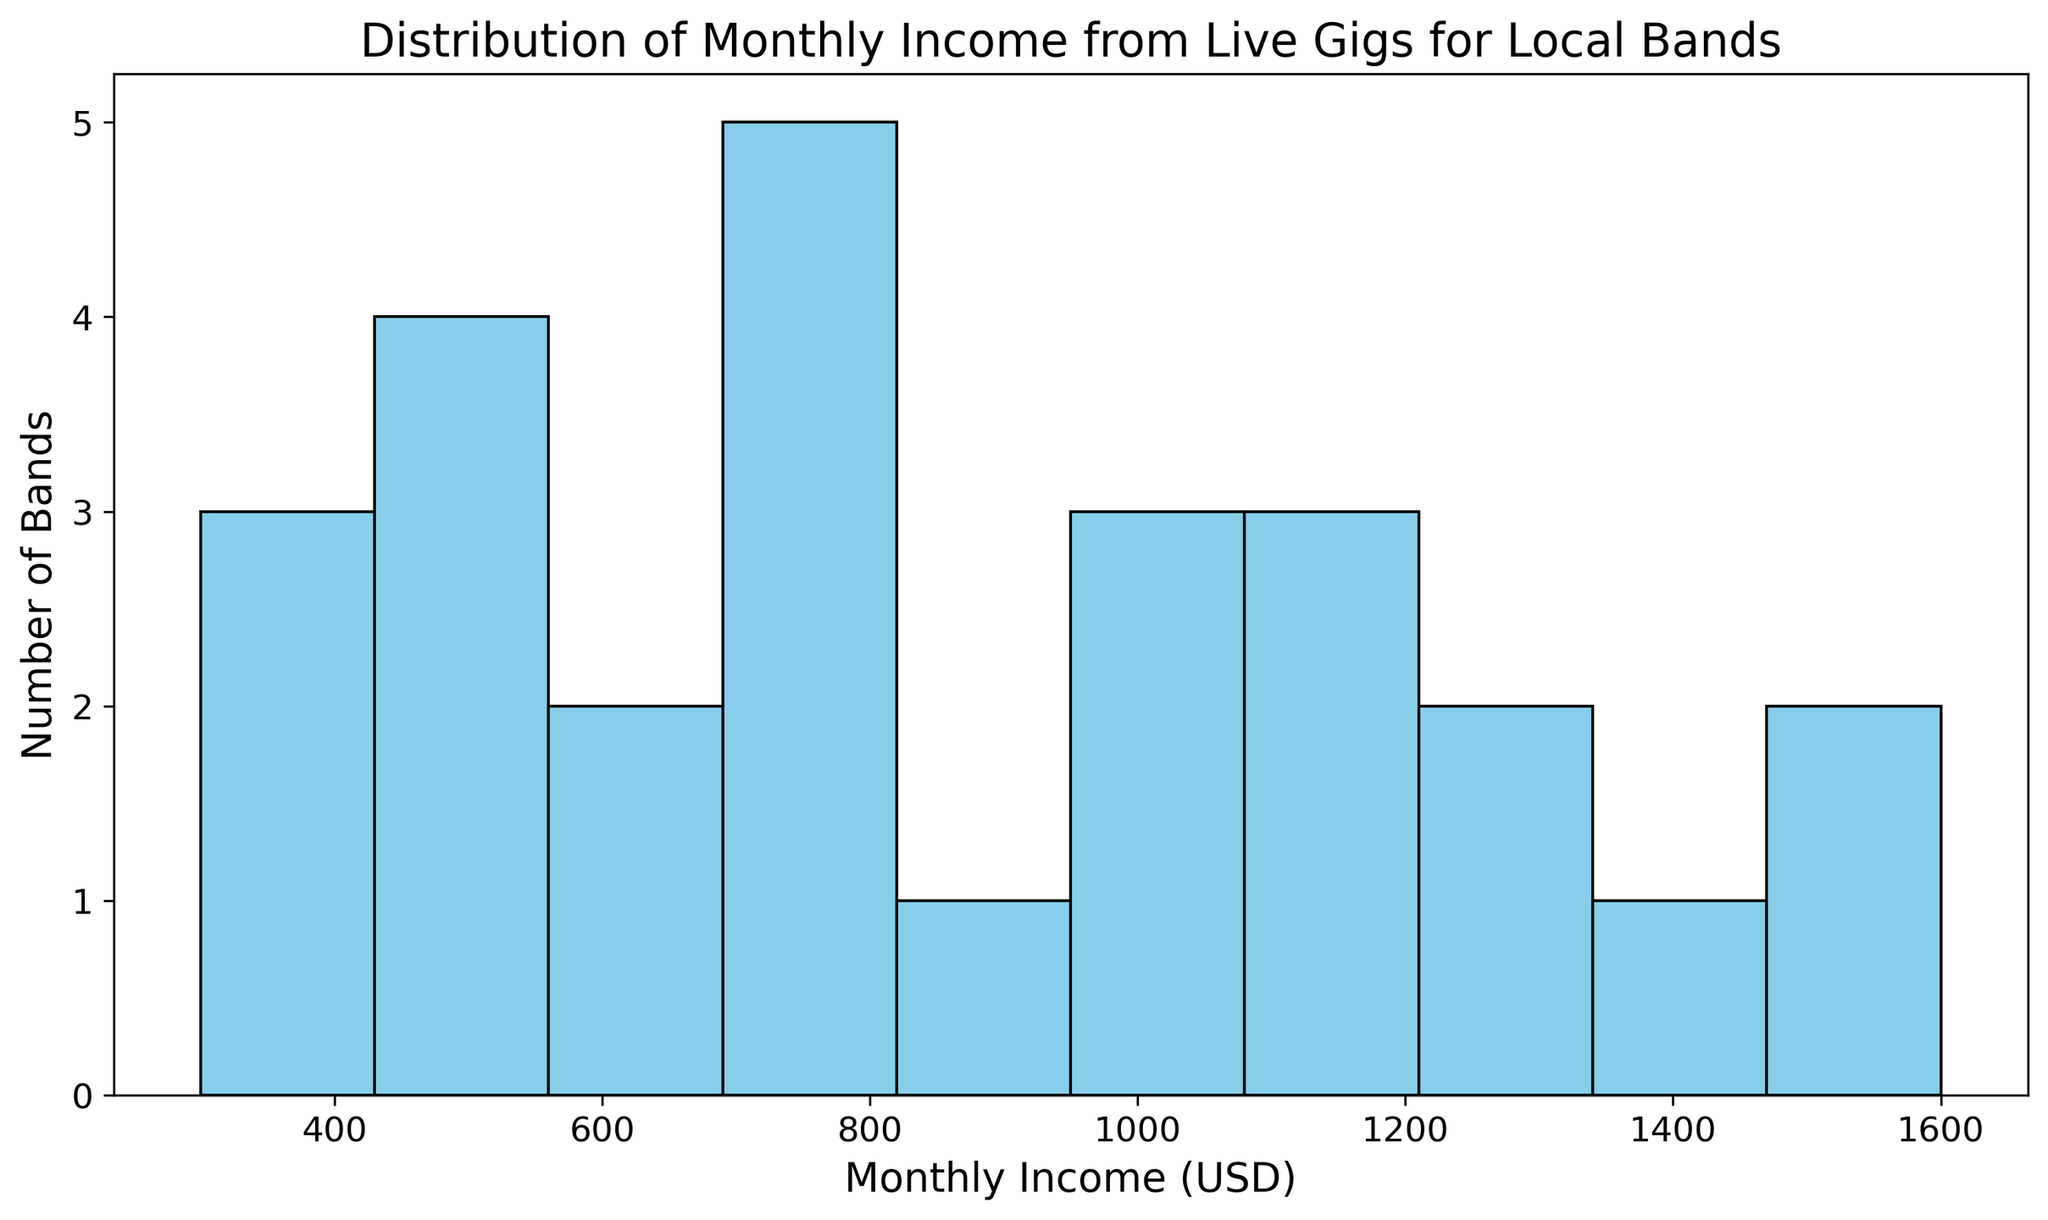What is the range of most bands' monthly income from live gigs? By observing the histogram, we can see the distribution of the bands' monthly income. The highest bars indicate the income range where most bands fall.
Answer: 400-800 USD Which income range has the highest number of bands? By looking at the height of the bars across different income ranges on the histogram, we see that the bar corresponding to the income range 400-600 USD is the tallest.
Answer: 400-600 USD How many bands have a monthly income above 1000 USD? Identify the bars that represent income ranges above 1000 USD and count the total number of bands in these ranges by looking at the bar heights.
Answer: 7 Compare the number of bands earning below 500 USD to those earning above 1500 USD. Which group is larger? Look at the bars corresponding to the income ranges below 500 USD and above 1500 USD. By comparing the heights of these bars, we can determine the larger group.
Answer: Bands earning below 500 USD What is the median monthly income from live gigs for local bands? To find the median, sort all the incomes and locate the middle value. In this case, with 26 bands, the middle values are the 13th and 14th when sorted, which are both in the 800-900 USD range.
Answer: 850 USD What is the total number of bands in the dataset? Sum the heights of all bars in the histogram. Each bar represents the number of bands within a specific income range.
Answer: 26 Which income range shows the lowest number of bands? By examining the histogram, find the bar with the smallest height. This represents the income range with the fewest bands.
Answer: 300-400 USD What is the average monthly income of these local bands? Calculate the average by summing all individual incomes and dividing by the total number of bands.
Answer: (500+1500+800+400+1000+700+1200+600+1300+400+900+1100+300+1600+1400+800+550+750+950+500+1250+480+600+1000+700+1200) / 26 = 896.15 USD 